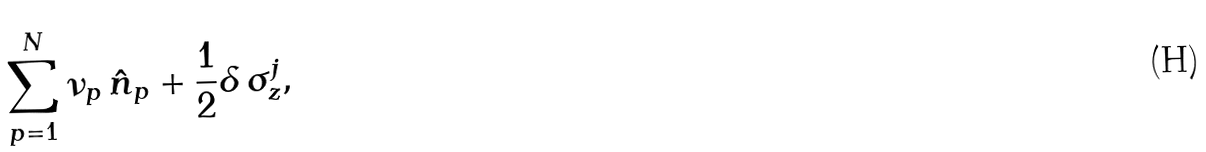<formula> <loc_0><loc_0><loc_500><loc_500>\sum _ { p = 1 } ^ { N } \nu _ { p } \, \hat { n } _ { p } + \frac { 1 } { 2 } \delta \, \sigma _ { z } ^ { j } ,</formula> 